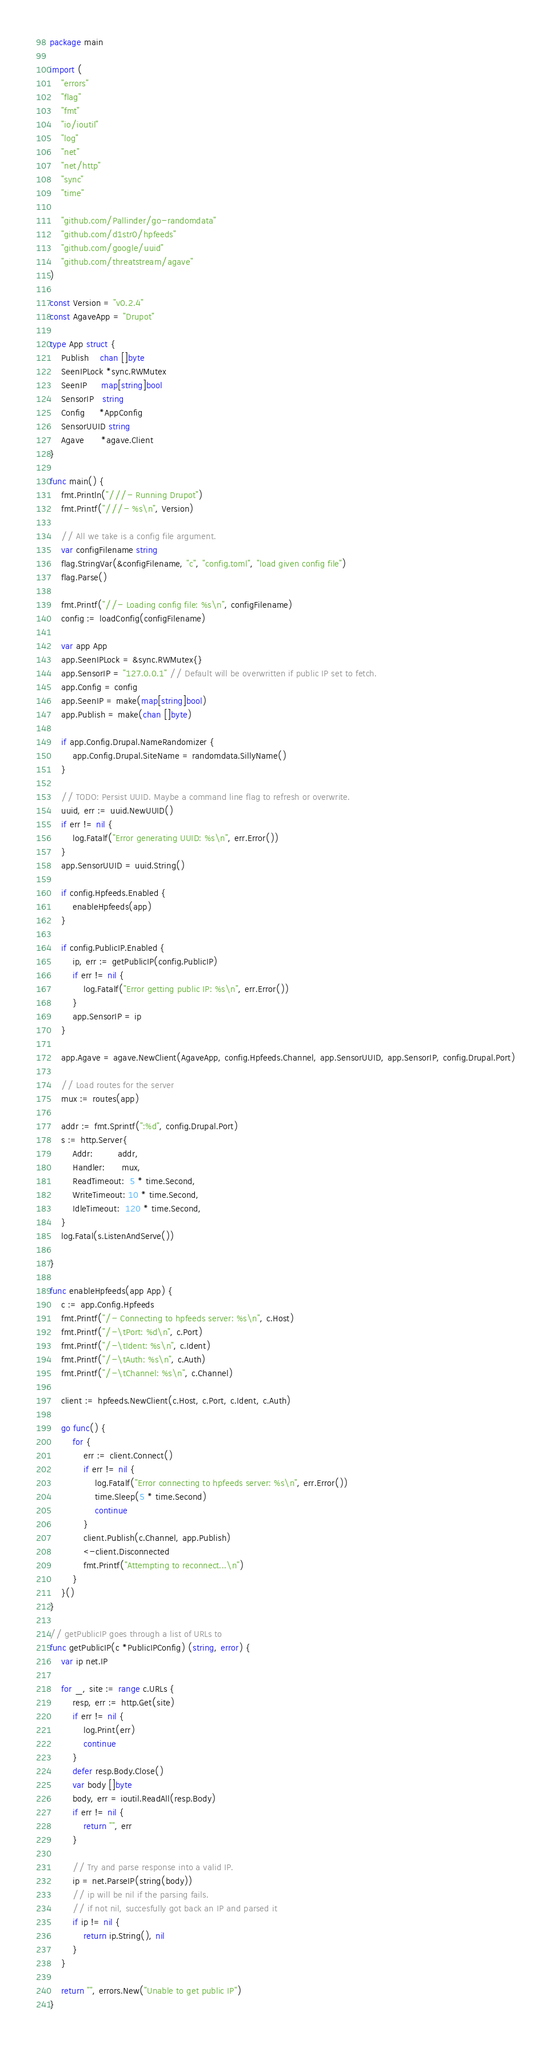<code> <loc_0><loc_0><loc_500><loc_500><_Go_>package main

import (
	"errors"
	"flag"
	"fmt"
	"io/ioutil"
	"log"
	"net"
	"net/http"
	"sync"
	"time"

	"github.com/Pallinder/go-randomdata"
	"github.com/d1str0/hpfeeds"
	"github.com/google/uuid"
	"github.com/threatstream/agave"
)

const Version = "v0.2.4"
const AgaveApp = "Drupot"

type App struct {
	Publish    chan []byte
	SeenIPLock *sync.RWMutex
	SeenIP     map[string]bool
	SensorIP   string
	Config     *AppConfig
	SensorUUID string
	Agave      *agave.Client
}

func main() {
	fmt.Println("///- Running Drupot")
	fmt.Printf("///- %s\n", Version)

	// All we take is a config file argument.
	var configFilename string
	flag.StringVar(&configFilename, "c", "config.toml", "load given config file")
	flag.Parse()

	fmt.Printf("//- Loading config file: %s\n", configFilename)
	config := loadConfig(configFilename)

	var app App
	app.SeenIPLock = &sync.RWMutex{}
	app.SensorIP = "127.0.0.1" // Default will be overwritten if public IP set to fetch.
	app.Config = config
	app.SeenIP = make(map[string]bool)
	app.Publish = make(chan []byte)

	if app.Config.Drupal.NameRandomizer {
		app.Config.Drupal.SiteName = randomdata.SillyName()
	}

	// TODO: Persist UUID. Maybe a command line flag to refresh or overwrite.
	uuid, err := uuid.NewUUID()
	if err != nil {
		log.Fatalf("Error generating UUID: %s\n", err.Error())
	}
	app.SensorUUID = uuid.String()

	if config.Hpfeeds.Enabled {
		enableHpfeeds(app)
	}

	if config.PublicIP.Enabled {
		ip, err := getPublicIP(config.PublicIP)
		if err != nil {
			log.Fatalf("Error getting public IP: %s\n", err.Error())
		}
		app.SensorIP = ip
	}

	app.Agave = agave.NewClient(AgaveApp, config.Hpfeeds.Channel, app.SensorUUID, app.SensorIP, config.Drupal.Port)

	// Load routes for the server
	mux := routes(app)

	addr := fmt.Sprintf(":%d", config.Drupal.Port)
	s := http.Server{
		Addr:         addr,
		Handler:      mux,
		ReadTimeout:  5 * time.Second,
		WriteTimeout: 10 * time.Second,
		IdleTimeout:  120 * time.Second,
	}
	log.Fatal(s.ListenAndServe())

}

func enableHpfeeds(app App) {
	c := app.Config.Hpfeeds
	fmt.Printf("/- Connecting to hpfeeds server: %s\n", c.Host)
	fmt.Printf("/-\tPort: %d\n", c.Port)
	fmt.Printf("/-\tIdent: %s\n", c.Ident)
	fmt.Printf("/-\tAuth: %s\n", c.Auth)
	fmt.Printf("/-\tChannel: %s\n", c.Channel)

	client := hpfeeds.NewClient(c.Host, c.Port, c.Ident, c.Auth)

	go func() {
		for {
			err := client.Connect()
			if err != nil {
				log.Fatalf("Error connecting to hpfeeds server: %s\n", err.Error())
				time.Sleep(5 * time.Second)
				continue
			}
			client.Publish(c.Channel, app.Publish)
			<-client.Disconnected
			fmt.Printf("Attempting to reconnect...\n")
		}
	}()
}

// getPublicIP goes through a list of URLs to
func getPublicIP(c *PublicIPConfig) (string, error) {
	var ip net.IP

	for _, site := range c.URLs {
		resp, err := http.Get(site)
		if err != nil {
			log.Print(err)
			continue
		}
		defer resp.Body.Close()
		var body []byte
		body, err = ioutil.ReadAll(resp.Body)
		if err != nil {
			return "", err
		}

		// Try and parse response into a valid IP.
		ip = net.ParseIP(string(body))
		// ip will be nil if the parsing fails.
		// if not nil, succesfully got back an IP and parsed it
		if ip != nil {
			return ip.String(), nil
		}
	}

	return "", errors.New("Unable to get public IP")
}
</code> 